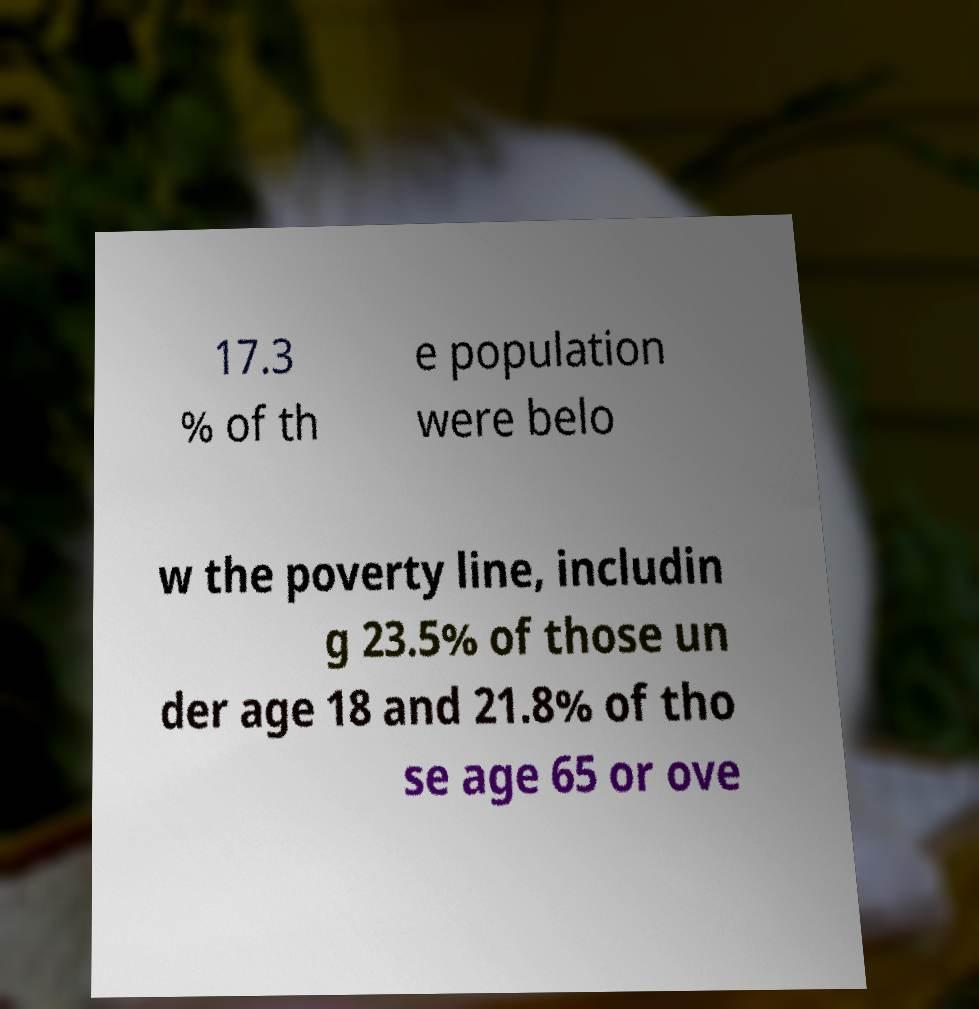I need the written content from this picture converted into text. Can you do that? 17.3 % of th e population were belo w the poverty line, includin g 23.5% of those un der age 18 and 21.8% of tho se age 65 or ove 